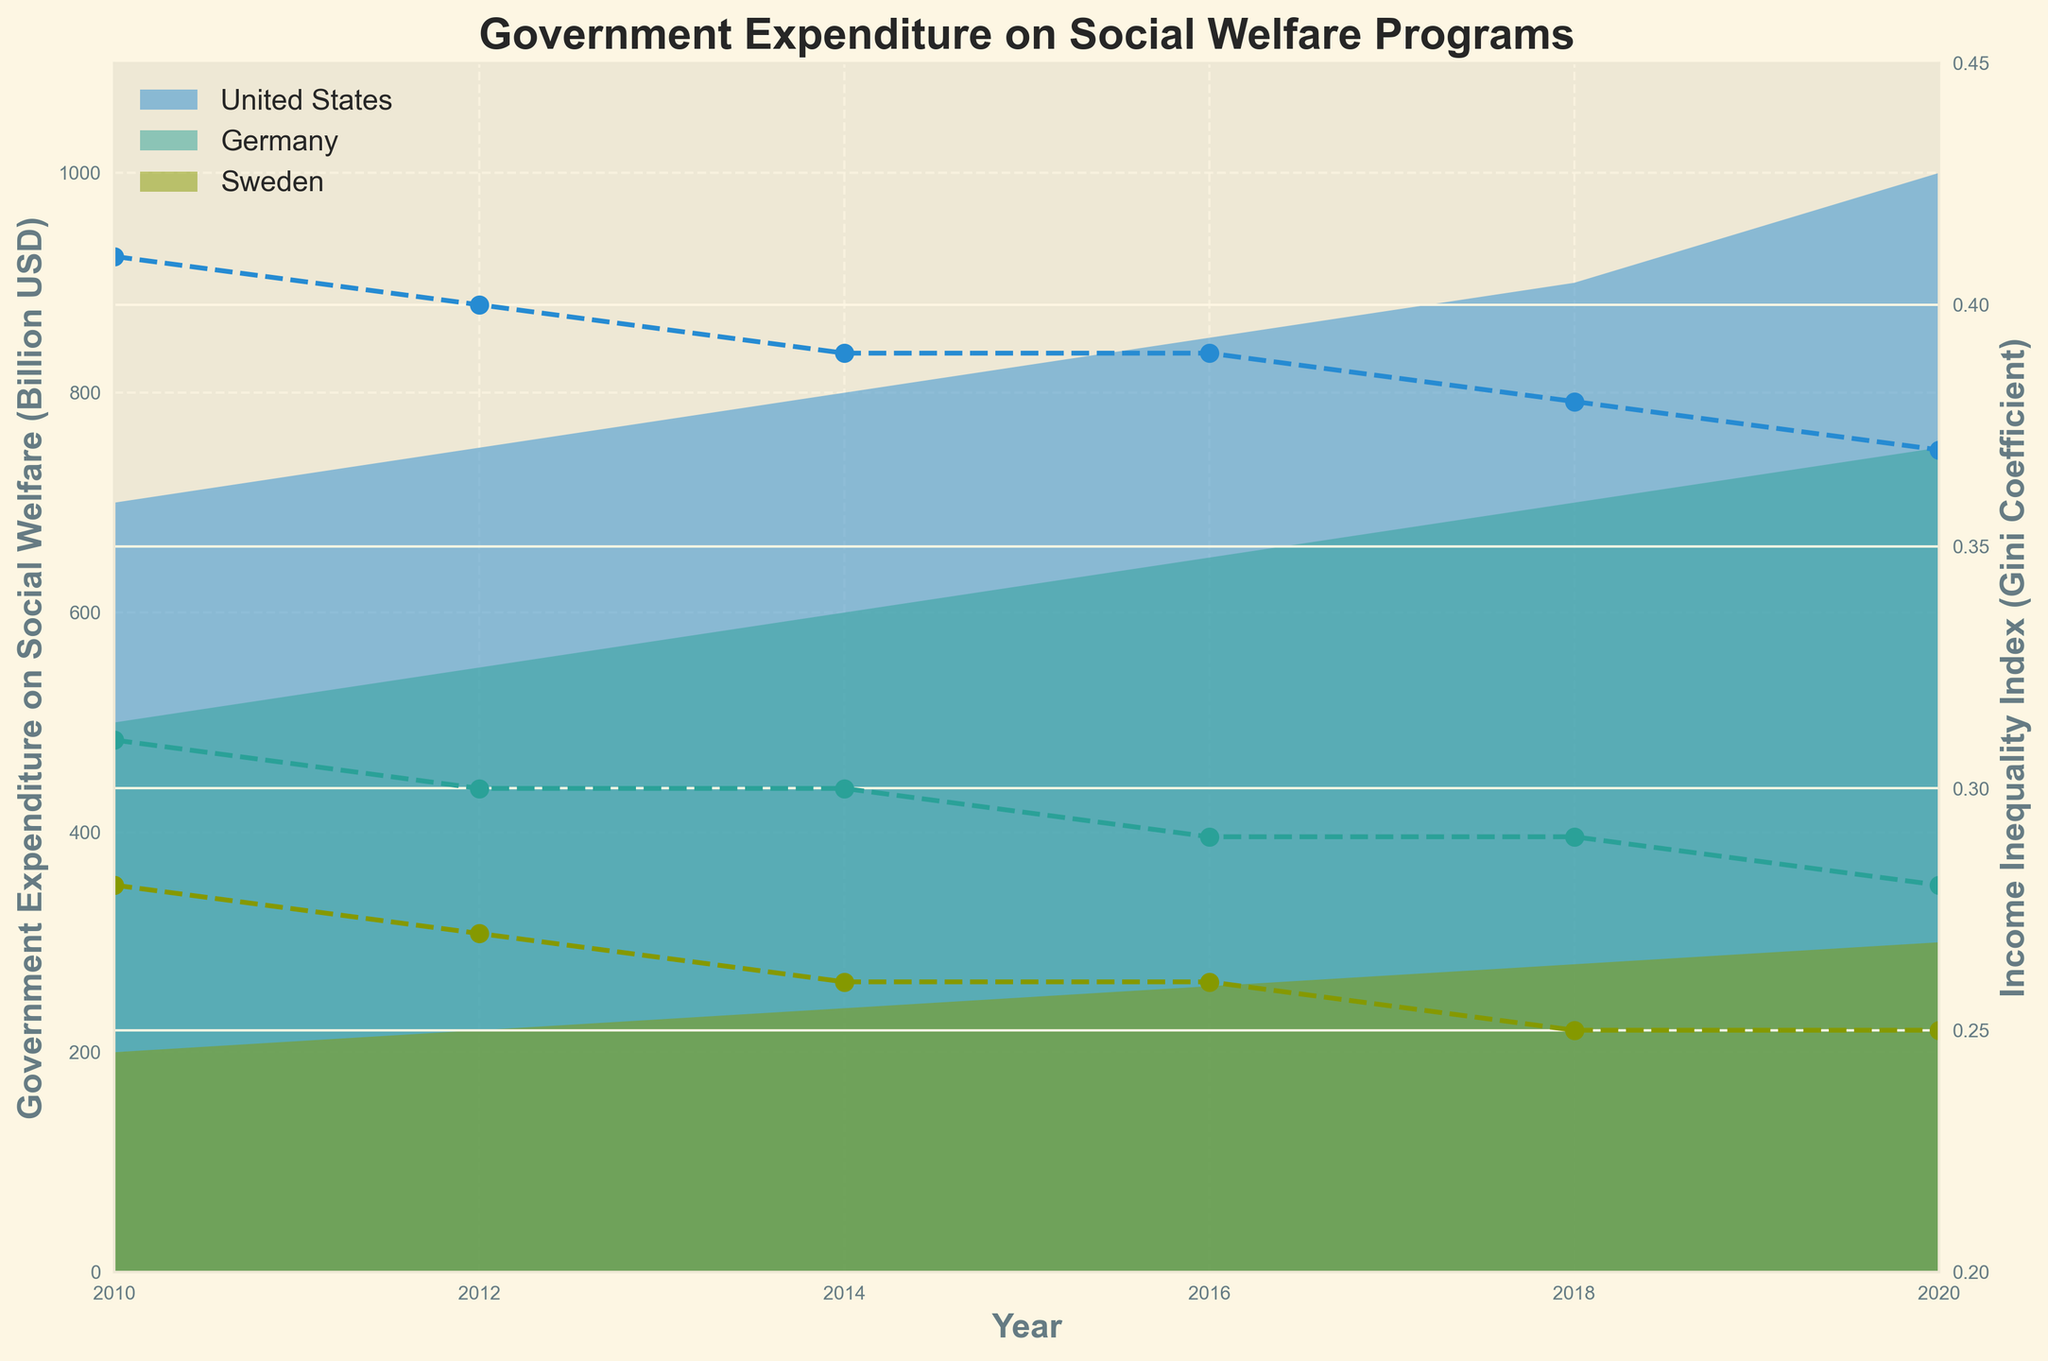What's the title of the plot? The title of the plot is a basic element that is usually located at the top center of the figure. Here, it summarizes the figure's content and helps to understand what the plot is about.
Answer: Government Expenditure on Social Welfare Programs What do the x-axis and y-axis represent? The x-axis typically represents the independent variable, and the y-axis the dependent variable. In this plot, the x-axis represents the year, and the y-axis on the left represents government expenditure on social welfare programs in billion USD.
Answer: x-axis: Year; y-axis: Government Expenditure on Social Welfare (Billion USD) How does the government expenditure on social welfare in Germany change from 2010 to 2020? To find this, look at the filled area for Germany in the plot. From left to right, observe the height of the area at different years. The data shows that expenditure increases steadily from 2010 to 2020.
Answer: Increases steadily Which country shows the lowest income inequality index (Gini Coefficient) in 2020? To determine this, inspect the line plots for each country at the year 2020 and compare their heights on the secondary y-axis (right). Sweden has the lowest Gini Coefficient in 2020.
Answer: Sweden How much did the US government expenditure on social welfare increase from 2010 to 2020? Find the government expenditure values for the US in 2010 and 2020 by looking at the filled area. Subtract the 2010 value from the 2020 value: 1000 - 700 = 300 billion USD.
Answer: 300 billion USD Compare the trend of government expenditure and the trend of the income inequality index for Sweden from 2010 to 2020. To compare these trends, look at both the area (for expenditure) and the line (for Gini Coefficient) over time for Sweden. Expenditure on social welfare increases steadily, while the Gini Coefficient decreases slightly.
Answer: Expenditure increases, Gini decreases slightly Which country experienced the smallest change in income inequality index from 2010 to 2020? Compare the Gini Coefficient lines for each country across the years 2010 to 2020. Identify the country with the smallest difference. Germany has the smallest change, from 0.31 to 0.28.
Answer: Germany What is the relationship between government expenditure on social welfare and income inequality in the United States? Analyze the trend of the filled area and the line plot for the United States. As government expenditure on social welfare increases, the income inequality index decreases, indicating an inverse relationship.
Answer: Inverse relationship How did the Gini Coefficient of Germany change between 2016 and 2020? Focus on the line plot for Germany between the years 2016 and 2020. The Gini Coefficient decreased from 0.29 to 0.28 during this period.
Answer: Decreased from 0.29 to 0.28 